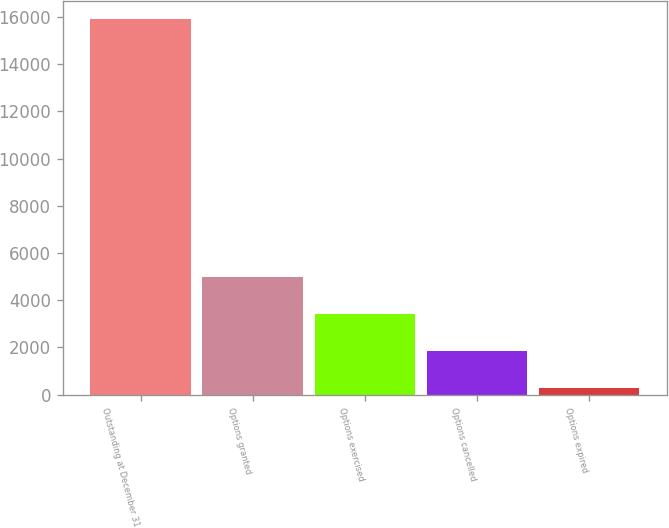Convert chart. <chart><loc_0><loc_0><loc_500><loc_500><bar_chart><fcel>Outstanding at December 31<fcel>Options granted<fcel>Options exercised<fcel>Options cancelled<fcel>Options expired<nl><fcel>15900<fcel>4975.8<fcel>3415.2<fcel>1854.6<fcel>294<nl></chart> 